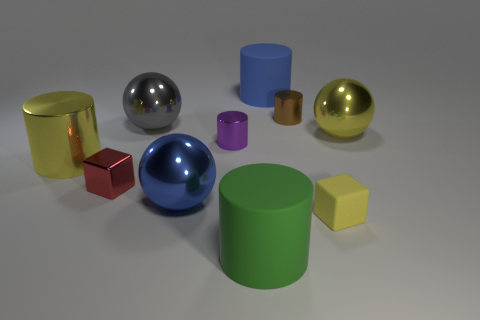Subtract all blue matte cylinders. How many cylinders are left? 4 Subtract 2 cylinders. How many cylinders are left? 3 Subtract all gray cylinders. Subtract all cyan blocks. How many cylinders are left? 5 Subtract all cubes. How many objects are left? 8 Subtract 0 green cubes. How many objects are left? 10 Subtract all big red spheres. Subtract all red cubes. How many objects are left? 9 Add 7 brown cylinders. How many brown cylinders are left? 8 Add 6 blue metallic balls. How many blue metallic balls exist? 7 